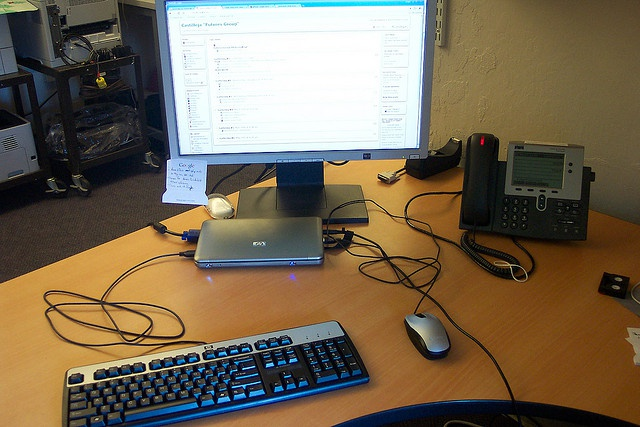Describe the objects in this image and their specific colors. I can see tv in green, white, and gray tones, keyboard in green, black, navy, and gray tones, laptop in green, gray, tan, and darkgreen tones, mouse in green, black, gray, and darkgray tones, and mouse in green, khaki, tan, lightyellow, and gray tones in this image. 